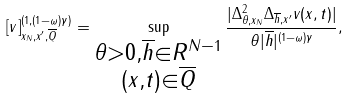<formula> <loc_0><loc_0><loc_500><loc_500>[ v ] _ { x _ { N } , x ^ { \prime } , \overline { Q } } ^ { ( 1 , ( 1 - \omega ) \gamma ) } = \sup _ { \substack { \theta > 0 , \overline { h } \in R ^ { N - 1 } \\ ( x , t ) \in \overline { Q } } } \frac { | \Delta _ { \theta , x _ { N } } ^ { 2 } \Delta _ { \overline { h } , x ^ { \prime } } v ( x , t ) | } { \theta | \overline { h } | ^ { ( 1 - \omega ) \gamma } } ,</formula> 